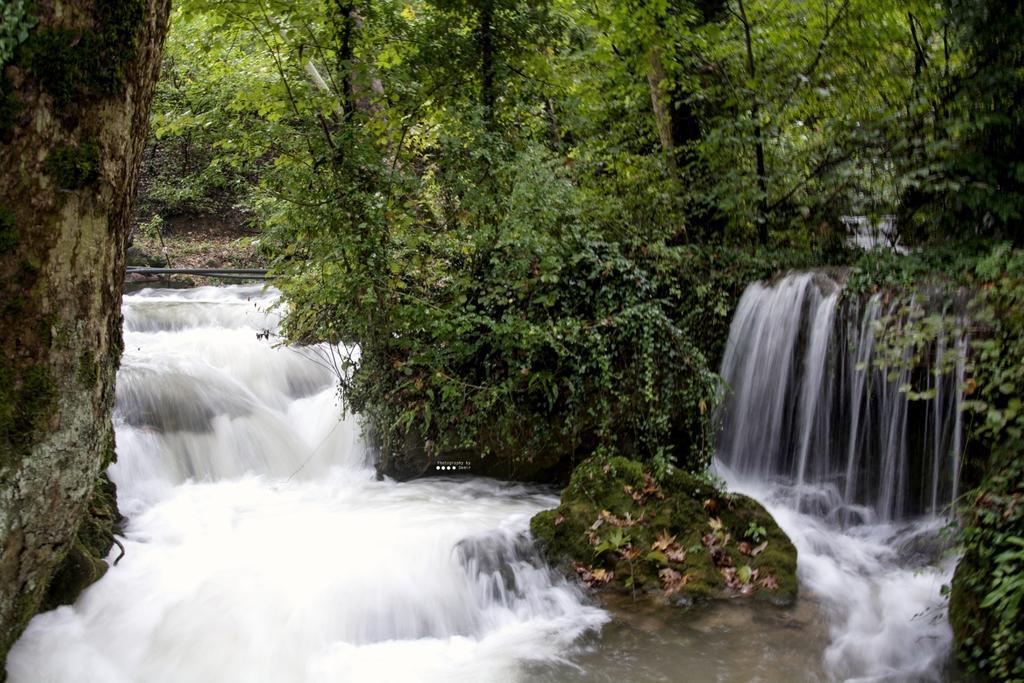Can you describe this image briefly? There is a waterfall as we can see at the bottom of this image, and trees in the background. 